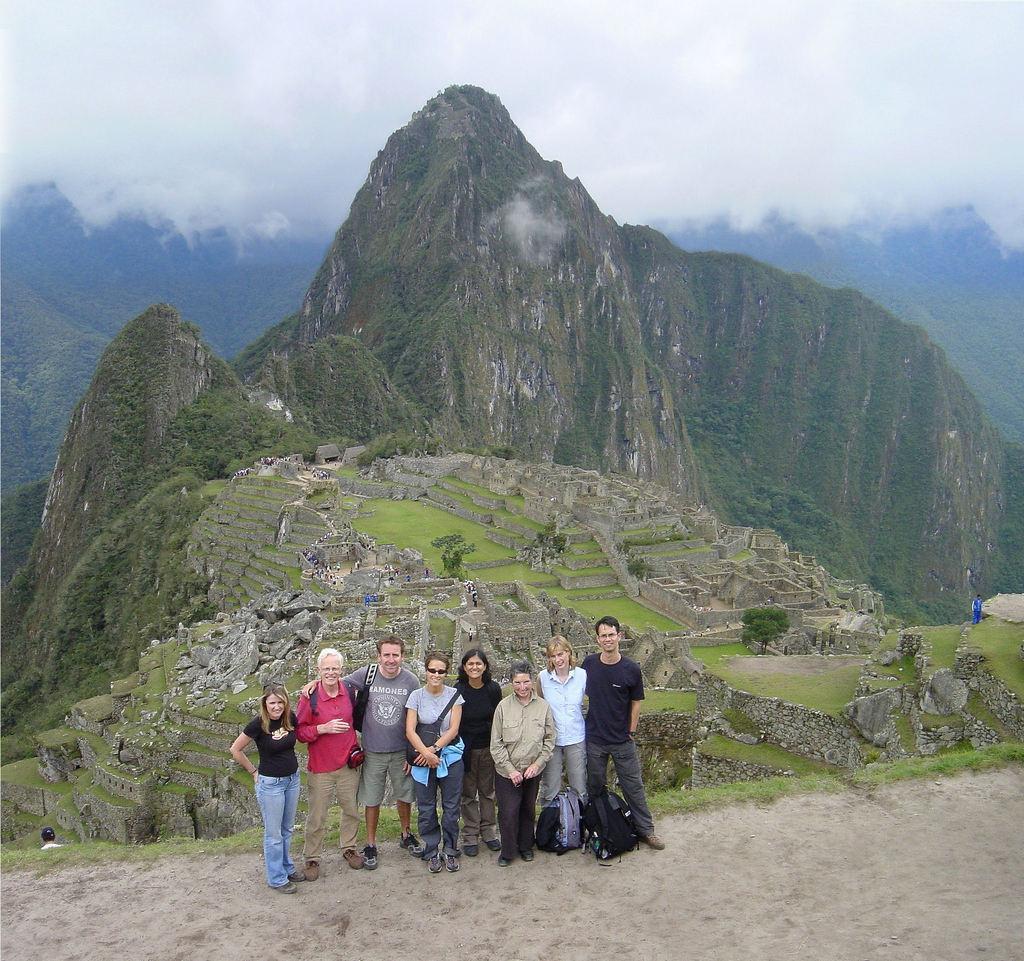Could you give a brief overview of what you see in this image? In the foreground I can see a group of people are standing on the ground and I can see bags. In the background I can see mountains, grass, fence, trees, fog and the sky. This image is taken, may be during a day. 